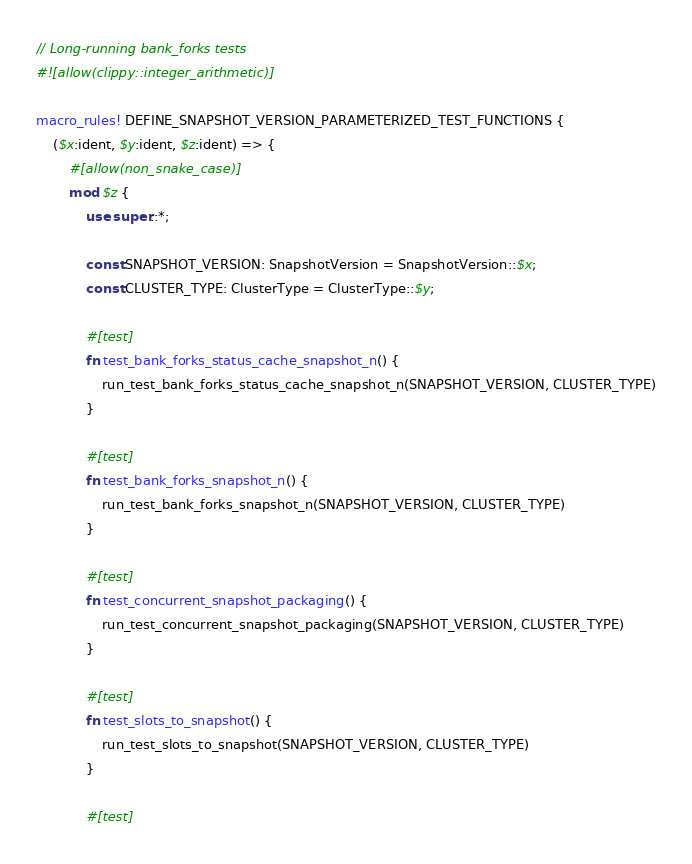<code> <loc_0><loc_0><loc_500><loc_500><_Rust_>// Long-running bank_forks tests
#![allow(clippy::integer_arithmetic)]

macro_rules! DEFINE_SNAPSHOT_VERSION_PARAMETERIZED_TEST_FUNCTIONS {
    ($x:ident, $y:ident, $z:ident) => {
        #[allow(non_snake_case)]
        mod $z {
            use super::*;

            const SNAPSHOT_VERSION: SnapshotVersion = SnapshotVersion::$x;
            const CLUSTER_TYPE: ClusterType = ClusterType::$y;

            #[test]
            fn test_bank_forks_status_cache_snapshot_n() {
                run_test_bank_forks_status_cache_snapshot_n(SNAPSHOT_VERSION, CLUSTER_TYPE)
            }

            #[test]
            fn test_bank_forks_snapshot_n() {
                run_test_bank_forks_snapshot_n(SNAPSHOT_VERSION, CLUSTER_TYPE)
            }

            #[test]
            fn test_concurrent_snapshot_packaging() {
                run_test_concurrent_snapshot_packaging(SNAPSHOT_VERSION, CLUSTER_TYPE)
            }

            #[test]
            fn test_slots_to_snapshot() {
                run_test_slots_to_snapshot(SNAPSHOT_VERSION, CLUSTER_TYPE)
            }

            #[test]</code> 